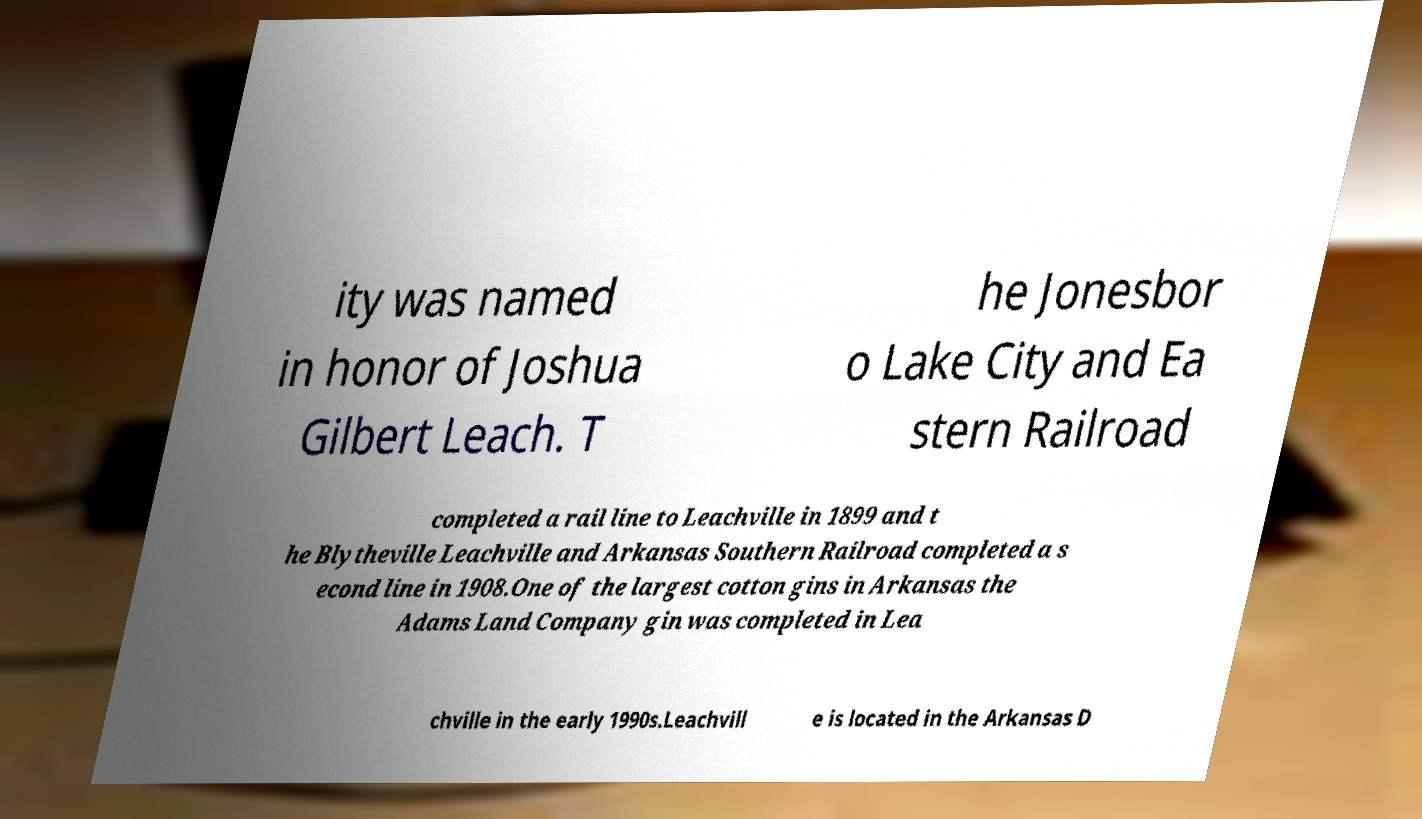What messages or text are displayed in this image? I need them in a readable, typed format. ity was named in honor of Joshua Gilbert Leach. T he Jonesbor o Lake City and Ea stern Railroad completed a rail line to Leachville in 1899 and t he Blytheville Leachville and Arkansas Southern Railroad completed a s econd line in 1908.One of the largest cotton gins in Arkansas the Adams Land Company gin was completed in Lea chville in the early 1990s.Leachvill e is located in the Arkansas D 